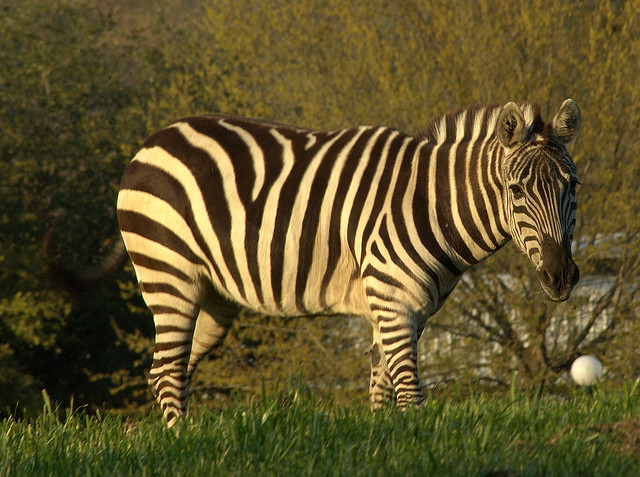<image>How much dust is around the zebra? I am not sure about the amount of dust around the zebra. It could be a lot, a little, not much, or none at all. How much dust is around the zebra? There is no dust around the zebra. 